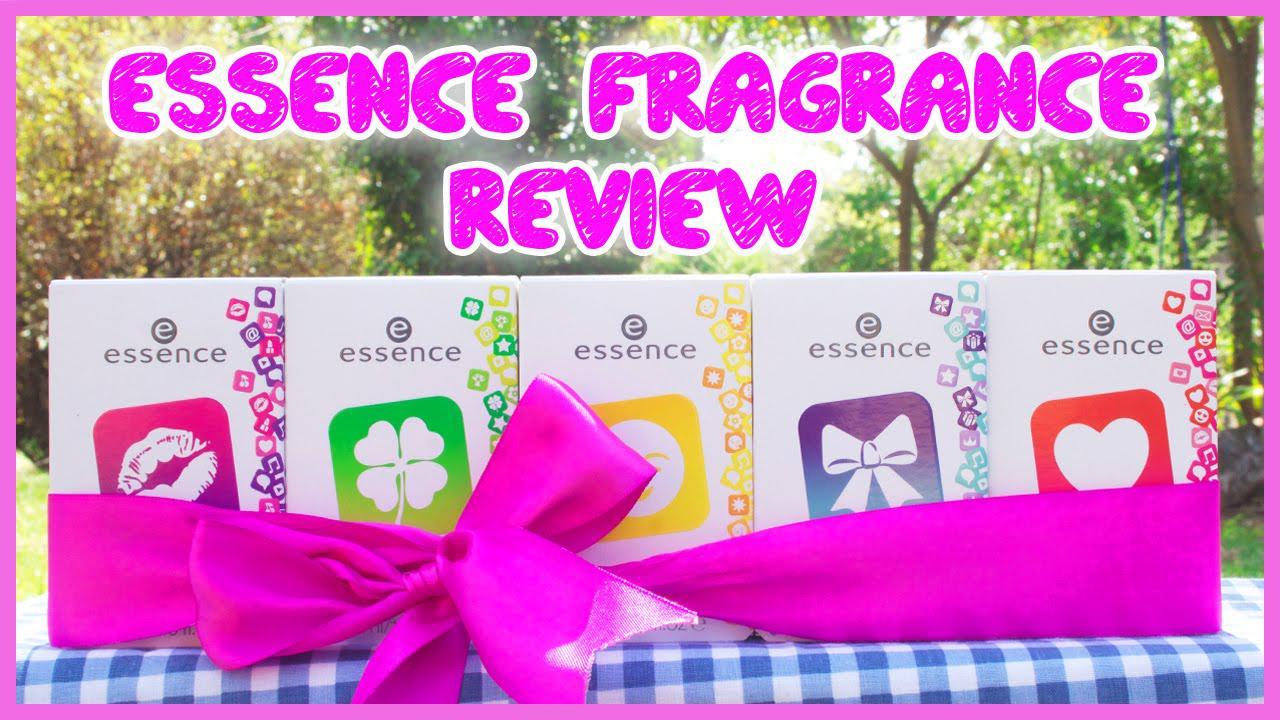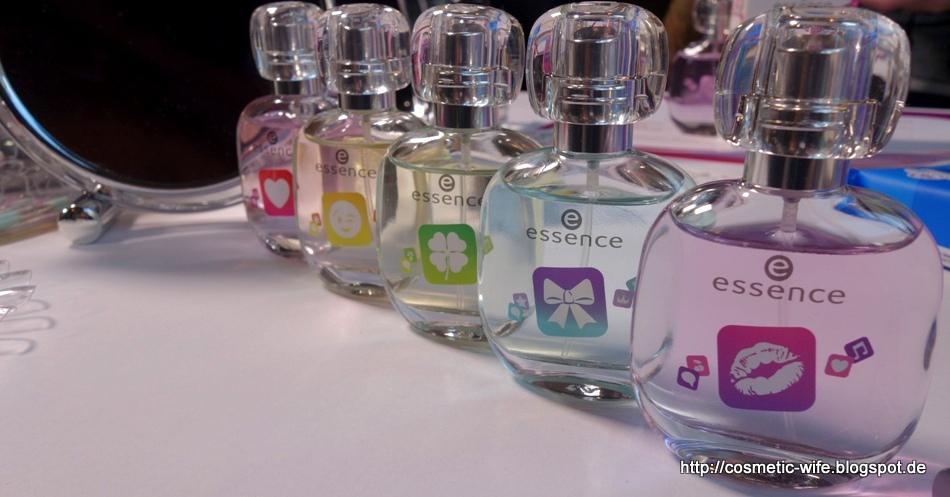The first image is the image on the left, the second image is the image on the right. Examine the images to the left and right. Is the description "The right image shows exactly one perfume in a circular bottle." accurate? Answer yes or no. No. 